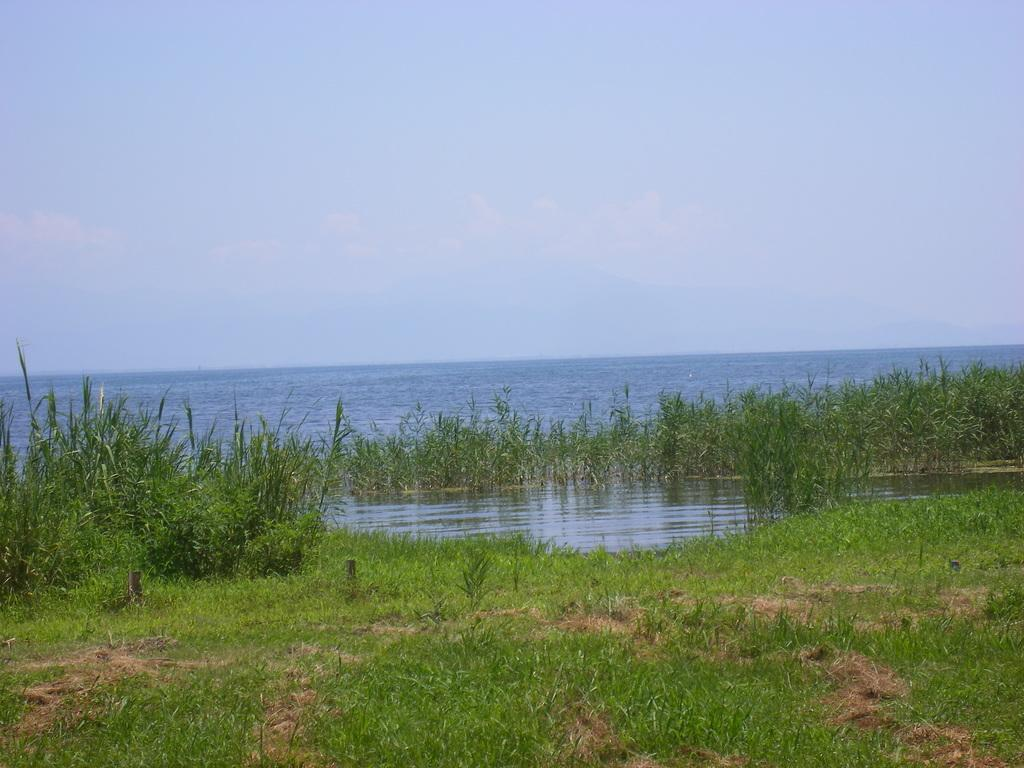What type of living organisms can be seen in the image? Plants and grass are visible in the image. What natural element can be seen in the image? There is water visible in the image. What part of the natural environment is visible in the image? The sky is visible in the background of the image. What type of bells can be heard ringing in the image? There are no bells present in the image, and therefore no such sound can be heard. How does the care for the plants in the image take place? The image does not provide information about the care for the plants, so it cannot be determined from the image. 